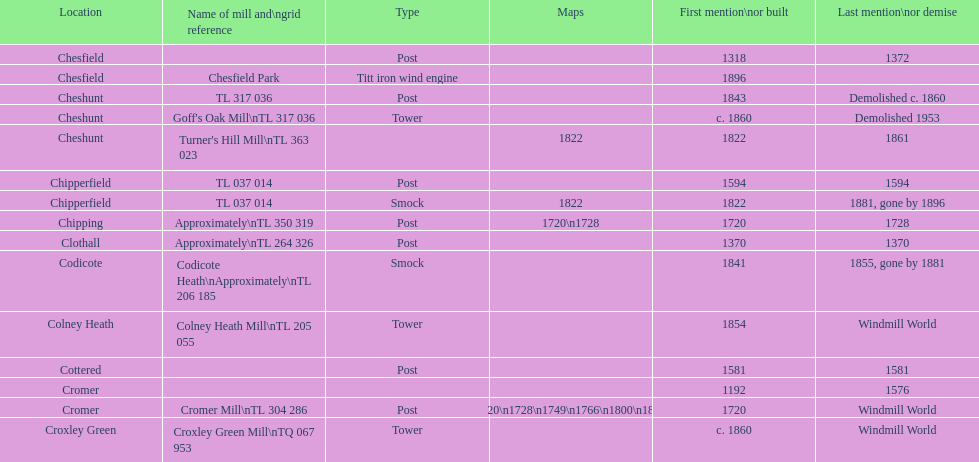In how many places are there no pictures available? 14. 